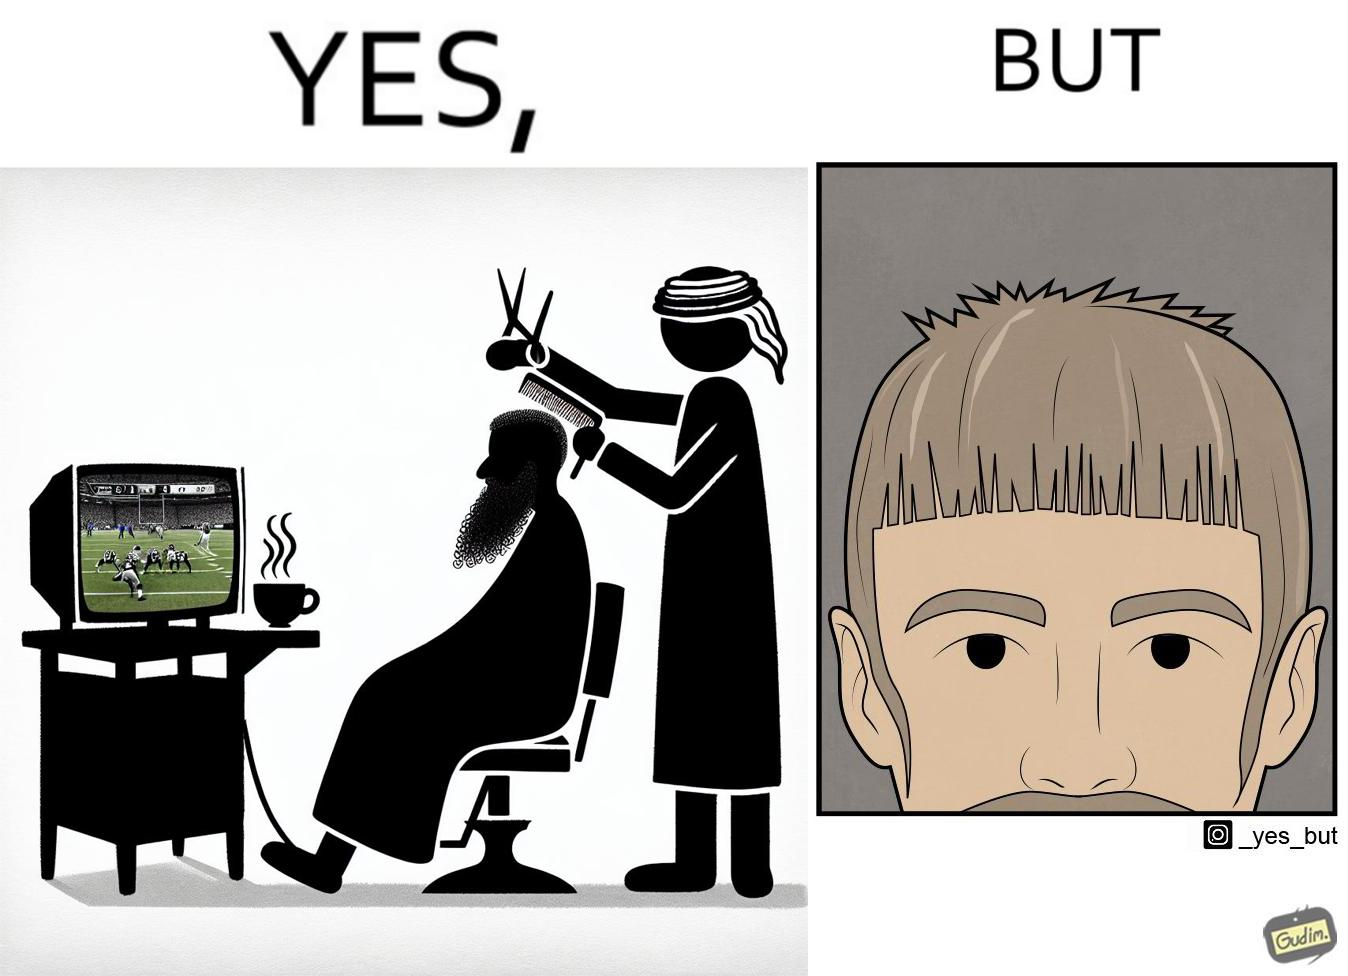Describe the content of this image. The image is ironic, because the sole purpose of the person was to get a hair cut but he became so much engrossed in the game that the barber wasn't able to cut his hairs properly. and even the saloon is providing so many facilities but they don't have a good hairdresser 